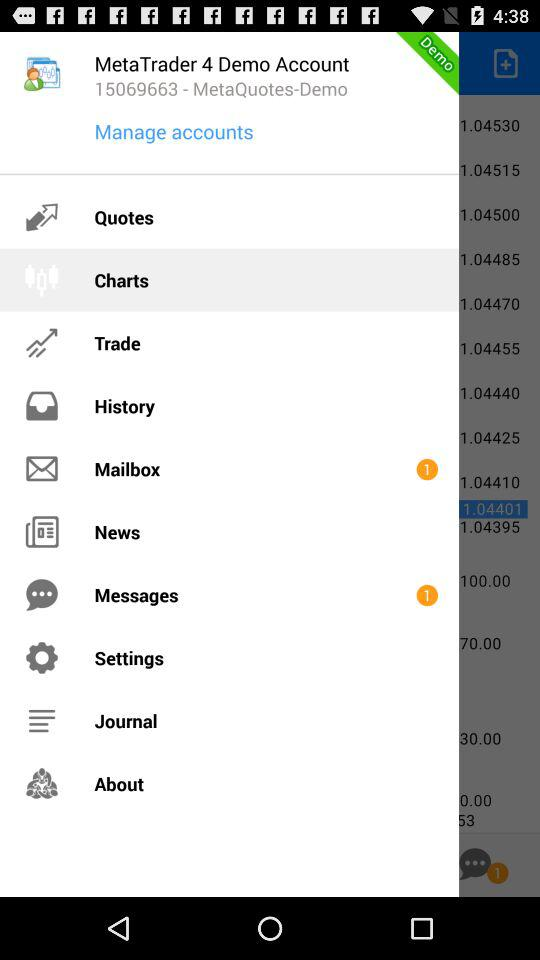What is the given number for "MetaQuotes-Demo"? The given number is 15069663. 